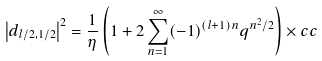Convert formula to latex. <formula><loc_0><loc_0><loc_500><loc_500>\left | d _ { l / 2 , 1 / 2 } \right | ^ { 2 } = \frac { 1 } { \eta } \left ( 1 + 2 \sum _ { n = 1 } ^ { \infty } ( - 1 ) ^ { ( l + 1 ) n } q ^ { n ^ { 2 } / 2 } \right ) \times c c</formula> 